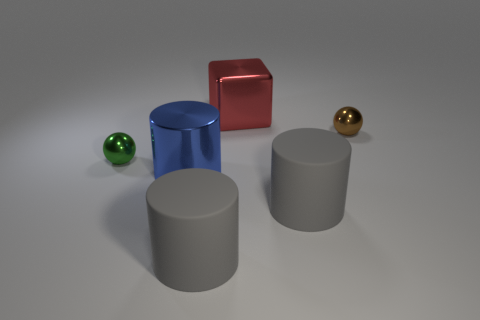What number of other things are there of the same color as the cube?
Provide a succinct answer. 0. How many things are shiny spheres on the left side of the big blue cylinder or spheres that are behind the green sphere?
Offer a very short reply. 2. There is a ball on the left side of the small thing that is behind the small green object; what is its size?
Make the answer very short. Small. The red shiny block is what size?
Provide a short and direct response. Large. There is a small object that is right of the green object; is it the same color as the large matte object that is on the left side of the block?
Offer a very short reply. No. How many other objects are there of the same material as the small green sphere?
Provide a succinct answer. 3. Are there any tiny brown shiny cubes?
Your answer should be compact. No. Do the large cylinder on the right side of the big red metallic object and the tiny brown object have the same material?
Give a very brief answer. No. What is the material of the other object that is the same shape as the small brown metal object?
Offer a very short reply. Metal. Is the number of brown objects less than the number of large green cylinders?
Your answer should be very brief. No. 